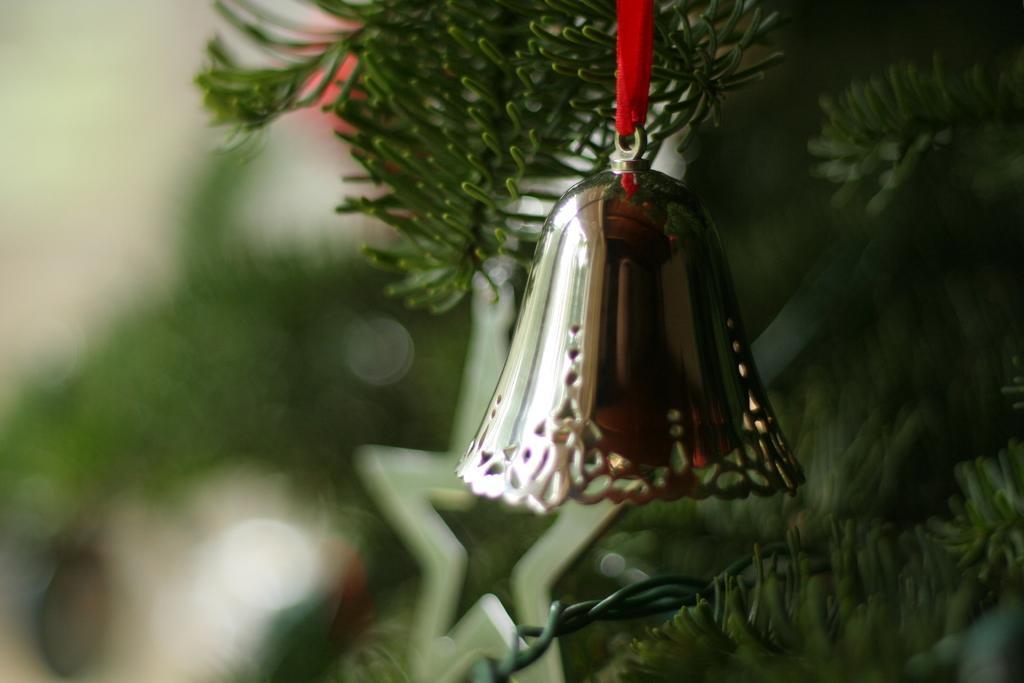How would you summarize this image in a sentence or two? In the middle of the picture, we see a bell which is hanged with a red color thread. Behind that, we see a Christmas tree. In the background, it is green in color and it is blurred in the background. 